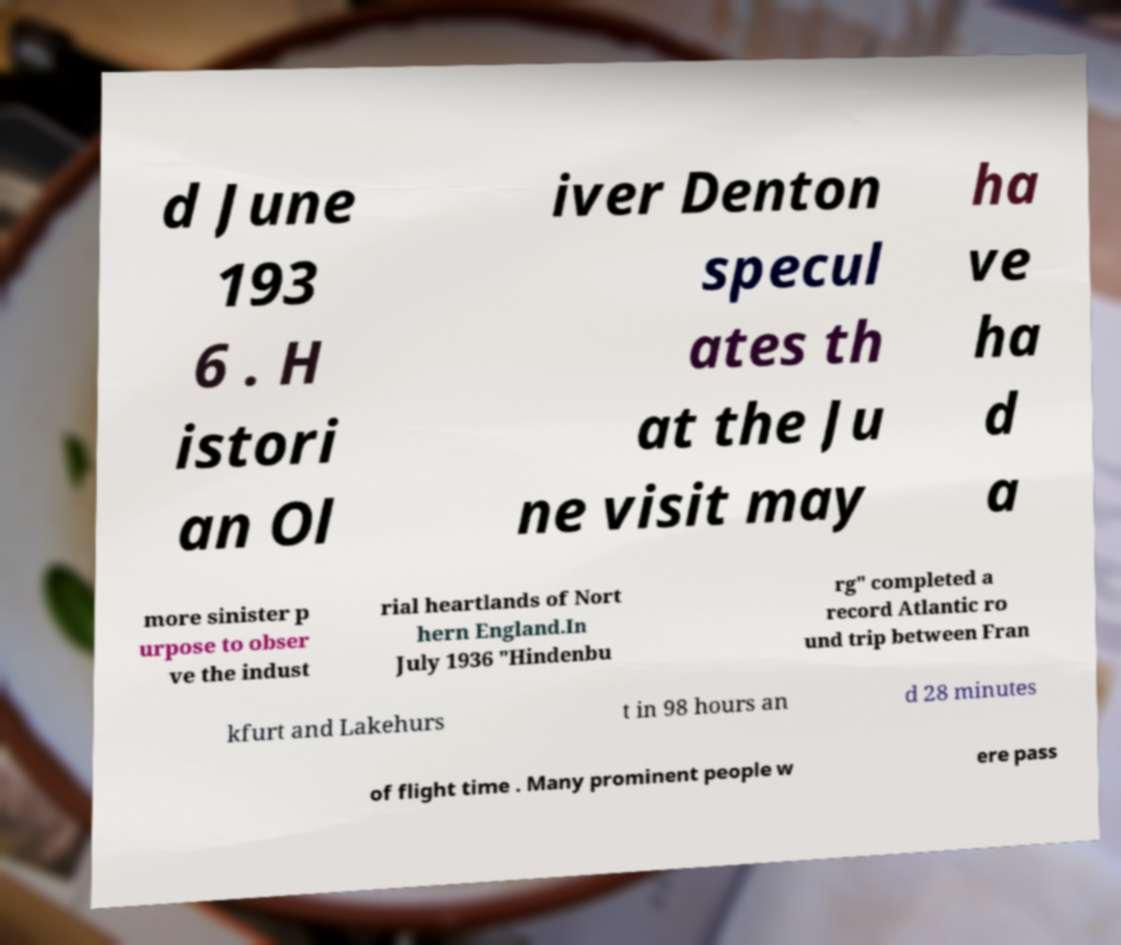What messages or text are displayed in this image? I need them in a readable, typed format. d June 193 6 . H istori an Ol iver Denton specul ates th at the Ju ne visit may ha ve ha d a more sinister p urpose to obser ve the indust rial heartlands of Nort hern England.In July 1936 "Hindenbu rg" completed a record Atlantic ro und trip between Fran kfurt and Lakehurs t in 98 hours an d 28 minutes of flight time . Many prominent people w ere pass 